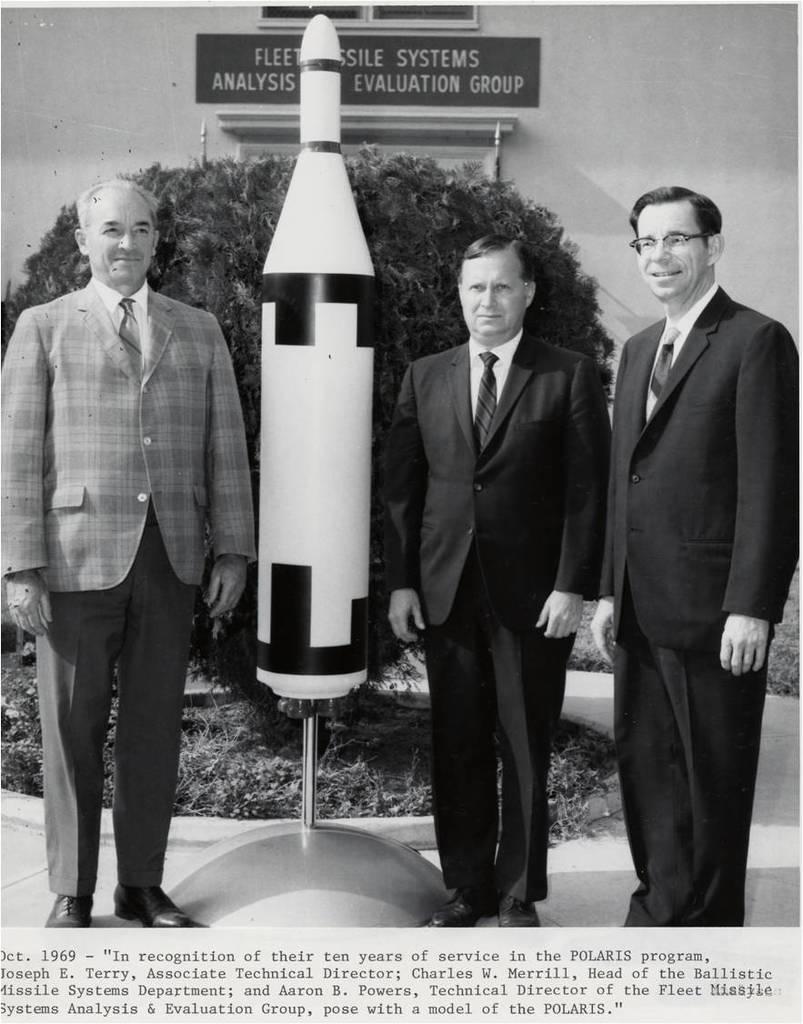Can you describe this image briefly? In the image there are three people and beside one person there is an object in the shape of a rocket and behind them there is a tree and in the background there is a wall, there is a board attached to the wall and there is some text at the bottom of the image. 